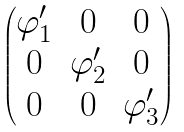<formula> <loc_0><loc_0><loc_500><loc_500>\begin{pmatrix} \varphi ^ { \prime } _ { 1 } & 0 & 0 \\ 0 & \varphi ^ { \prime } _ { 2 } & 0 \\ 0 & 0 & \varphi ^ { \prime } _ { 3 } \end{pmatrix}</formula> 